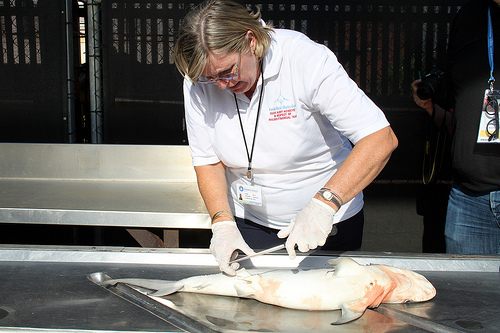<image>
Can you confirm if the fish is under the table? No. The fish is not positioned under the table. The vertical relationship between these objects is different. 